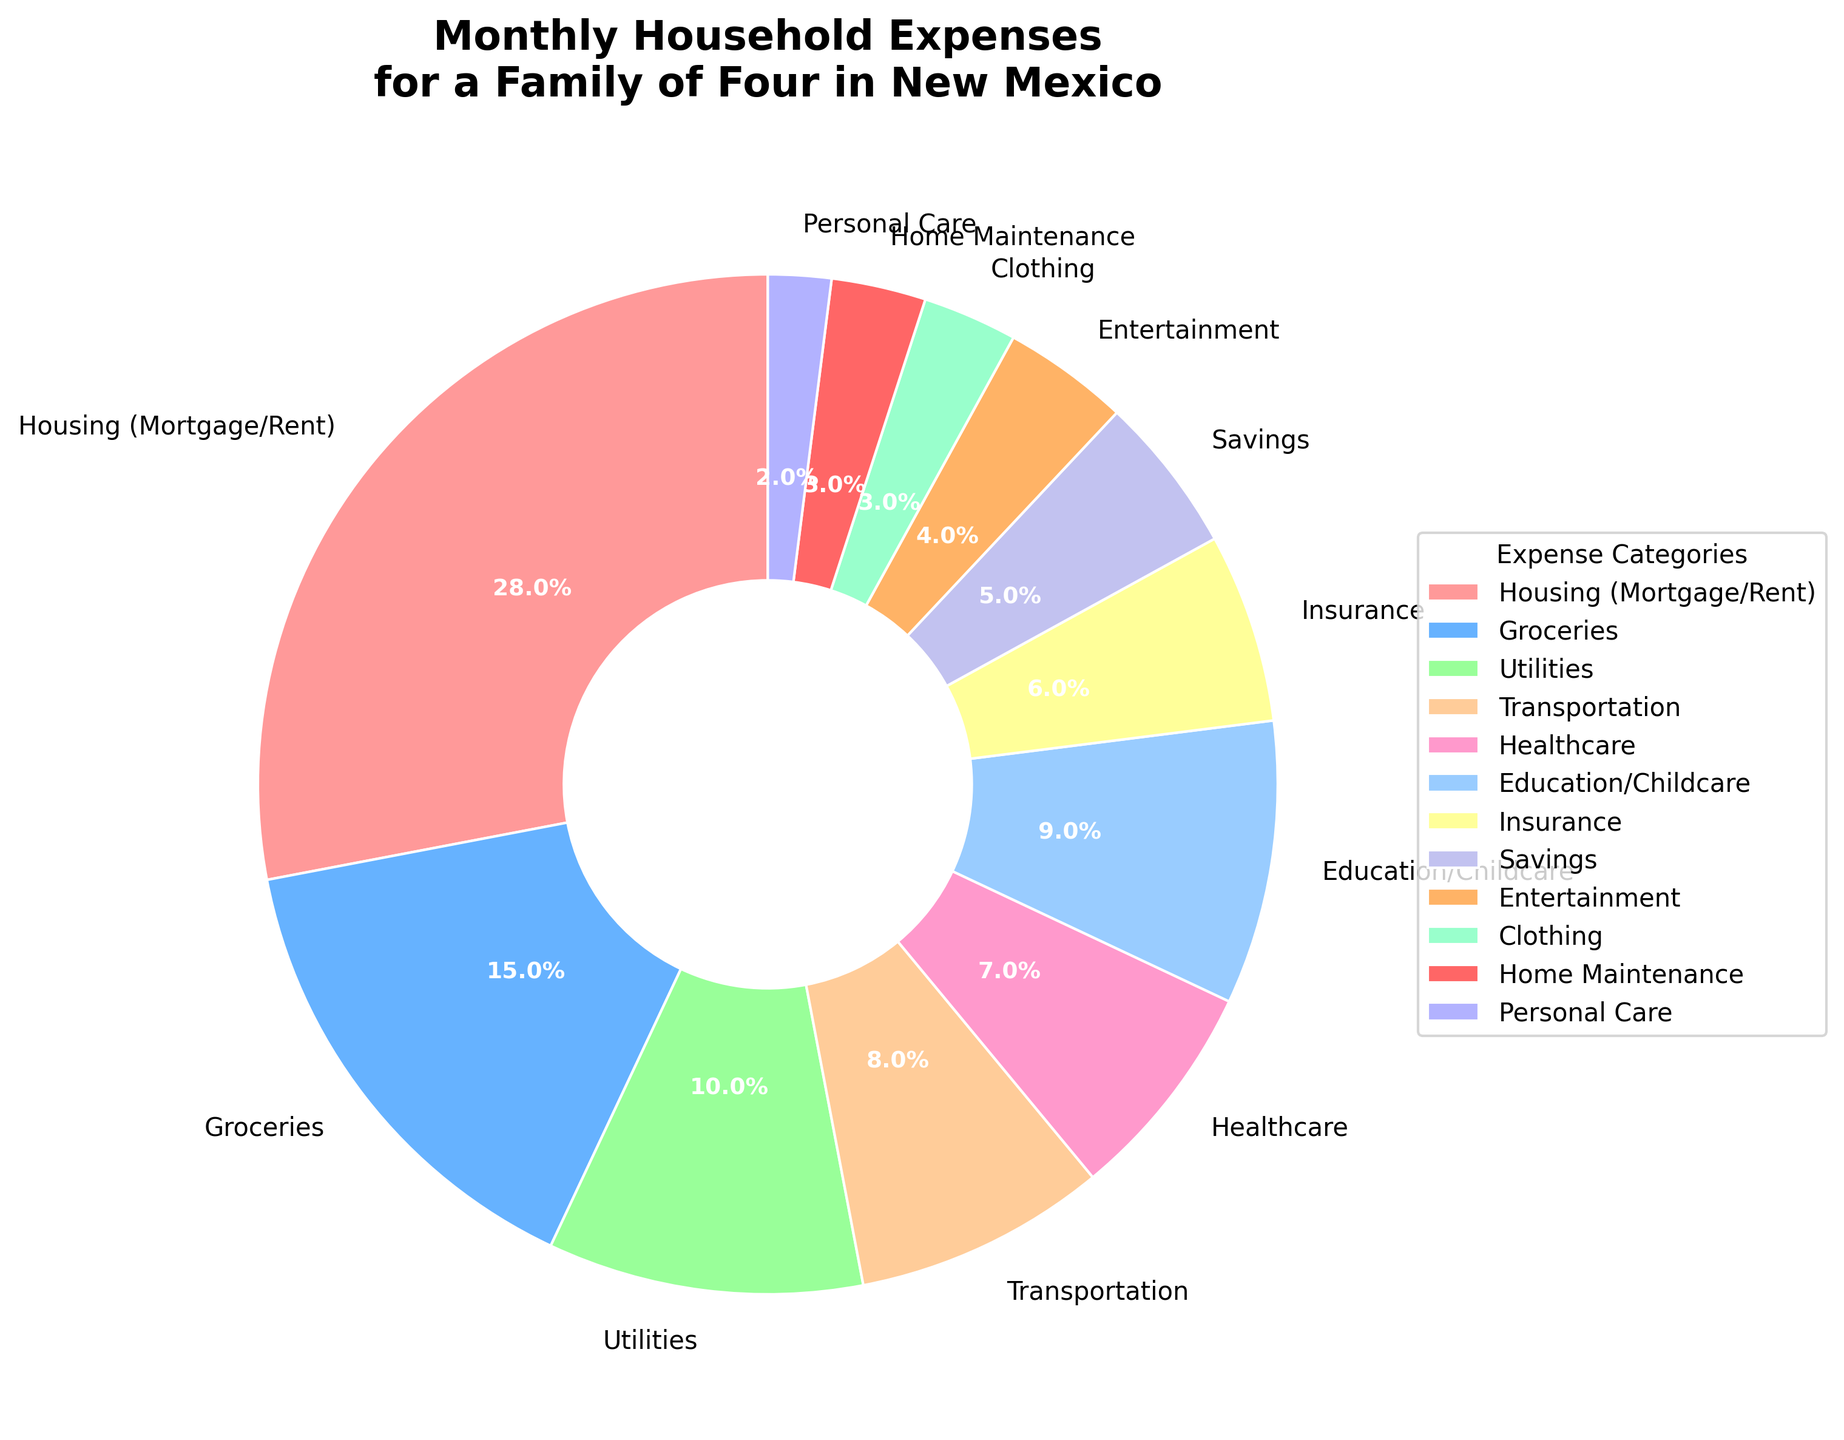What category has the highest percentage in the pie chart? The category with the highest percentage can be identified by looking for the largest wedge in the pie chart. In this chart, "Housing (Mortgage/Rent)" has the largest wedge.
Answer: Housing (Mortgage/Rent) Which category allocation is closest to the national average savings rate of around 5%? By observing the pie chart wedges and their labels, the segment marked "Savings" matches the 5% mentioned.
Answer: Savings Which categories together constitute more than half of the household expenses? By summing up the percentages of the categories with the largest wedges until over 50% is reached: Housing (28%) + Groceries (15%) + Utilities (10%) together constitute 53%, which is over half.
Answer: Housing, Groceries, and Utilities How does the percentage for Transportation compare to that for Healthcare? To compare, look at the wedges labeled "Transportation" and "Healthcare". The pie chart shows 8% for Transportation and 7% for Healthcare.
Answer: Transportation is more than Healthcare What is the combined percentage of Education/Childcare and Entertainment? Add the percentages of Education/Childcare (9%) and Entertainment (4%).
Answer: 13% Is the percentage spent on Personal Care greater than that on Home Maintenance? By checking the wedges labeled "Personal Care" (2%) and "Home Maintenance" (3%), it is clear that Personal Care is less.
Answer: No How much more is spent on Groceries compared to Insurance? Subtract Insurance (6%) from Groceries (15%). 15% - 6% = 9%.
Answer: 9% What percentage of household expenses is allocated to non-essential areas (Entertainment and Clothing)? Add the percentages of Entertainment (4%) and Clothing (3%).
Answer: 7% What is the difference in percentage between the highest and lowest categories? Subtract the lowest percentage (Personal Care, 2%) from the highest percentage (Housing, 28%). 28% - 2% = 26%.
Answer: 26% Which category is represented by the wedge with the light blue color? The wedge represented by the light blue color in the custom color palette used in the chart is "Groceries".
Answer: Groceries 